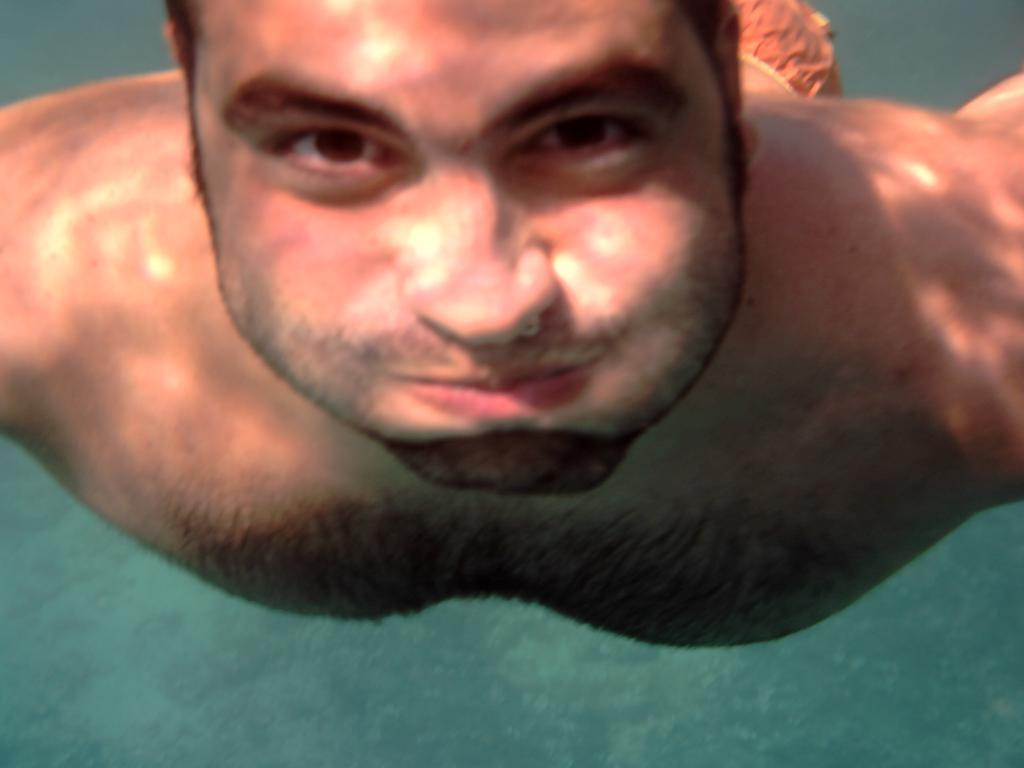What is the main subject of the image? There is a person in the image. Where is the person located in the image? The person is inside the water. What color is the water in the image? The water is in green color. What type of tax can be seen being paid by the person in the image? There is no tax being paid in the image; it features a person inside green-colored water. How many bees are visible in the image? There are no bees present in the image. 